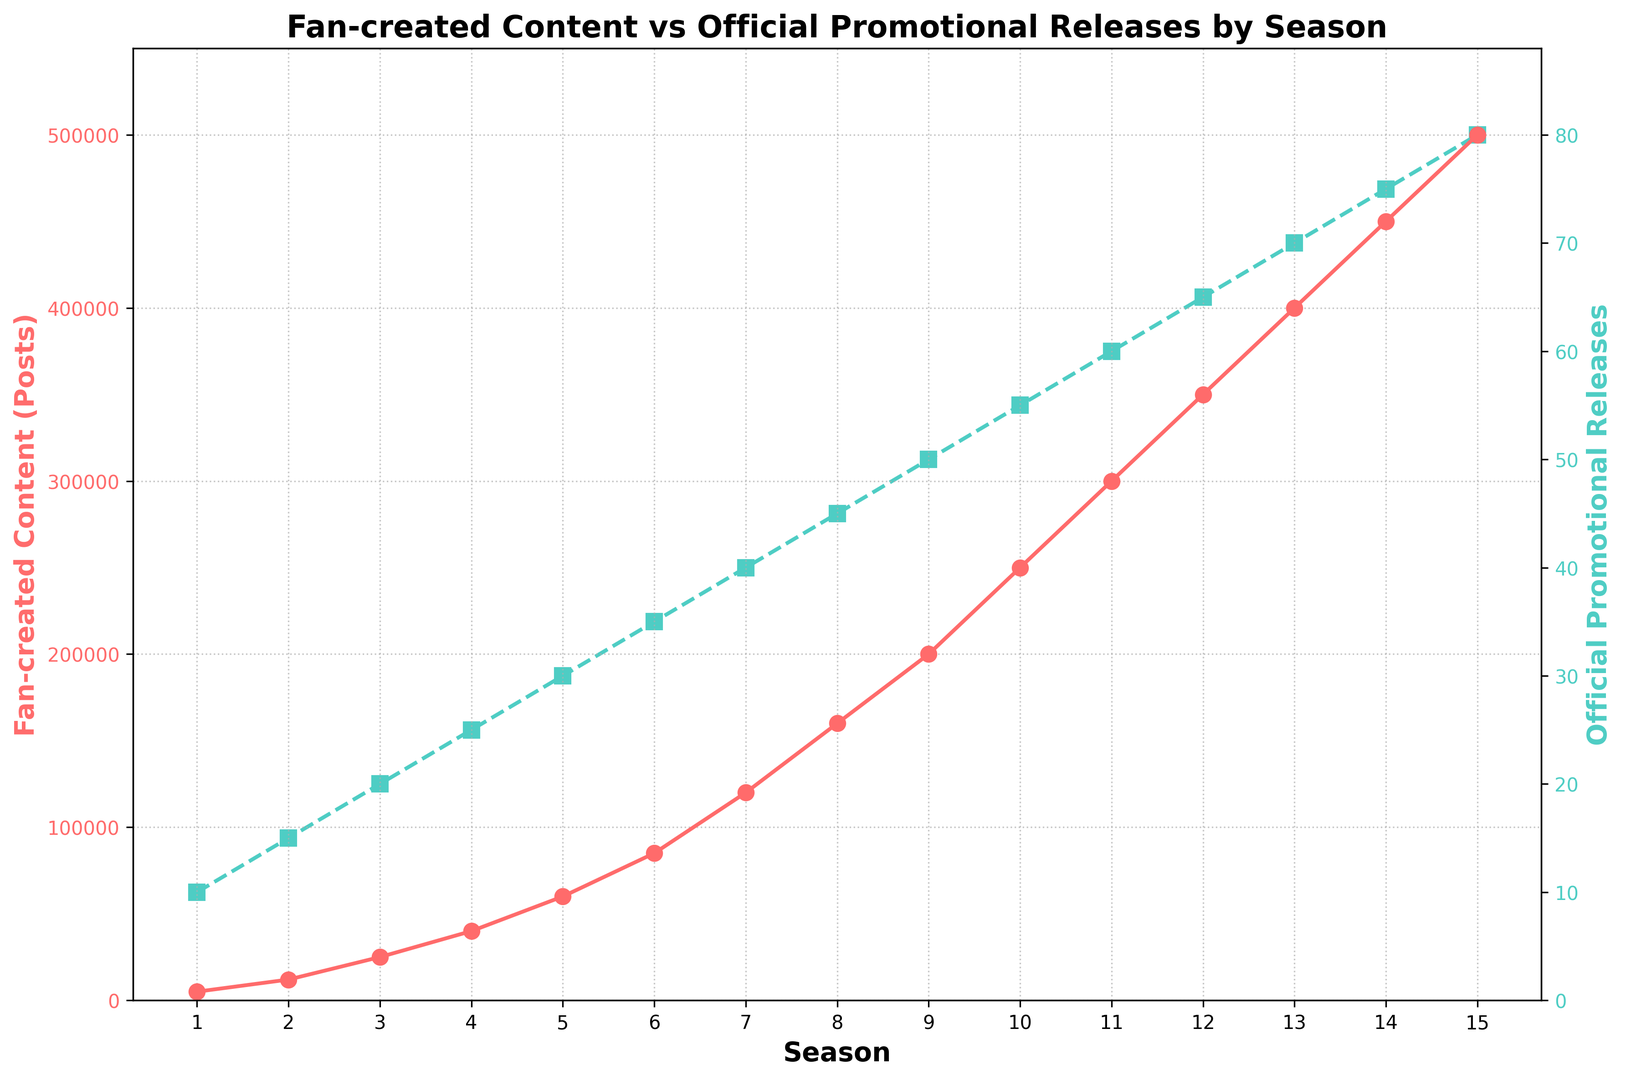How does the trend of Fan-created Content compare to Official Promotional Releases over the seasons? The Fan-created Content (Posts) consistently increases more steeply compared to Official Promotional Releases across all seasons as evidenced by the curve for Fan-created Content rising more sharply.
Answer: Fan-created Content increases more steeply In which season do Fan-created Content Posts and Official Promotional Releases show the maximum values? The maximum values for Fan-created Content Posts and Official Promotional Releases are in Season 15, where Fan-created Content posts reach 500,000, and Official Promotional Releases reach 80.
Answer: Season 15 What is the approximate ratio of Fan-created Content Posts to Official Promotional Releases in Season 10? The ratio of Fan-created Content Posts (250,000) to Official Promotional Releases (55) in Season 10 is approximately 250,000 / 55 ≈ 4545.
Answer: 4545 Between which consecutive seasons is there the largest increase in Fan-created Content Posts? The largest increase in Fan-created Content occurs between Season 8 (160,000 posts) and Season 9 (200,000 posts), which is an increase of 40,000 posts.
Answer: Between Season 8 and Season 9 Compare the rate of increase in Fan-created Content Posts with the rate of increase in Official Promotional Releases between Season 1 and Season 5. From Season 1 (5,000 posts) to Season 5 (60,000 posts), Fan-created Content Posts increase by 55,000. From Season 1 (10 releases) to Season 5 (30 releases), Official Promotional Releases increase by 20. The rate of increase for Fan-created Content is much higher.
Answer: Fan-created Content increases much more Which seasons show a similar rate of increase in both Fan-created Content Posts and Official Promotional Releases? Between Season 6 (85,000 posts, 35 releases) and Season 7 (120,000 posts, 40 releases), the increase is 35,000 posts and 5 releases respectively. This shows a similar incremental growth rate for both.
Answer: Between Season 6 and Season 7 Calculate the average number of Fan-created Content Posts over all seasons. Sum all the Fan-created Content Posts (5000 + 12000 + 25000 + 40000 + 60000 + 85000 + 120000 + 160000 + 200000 + 250000 + 300000 + 350000 + 400000 + 450000 + 500000) and divide by the number of seasons (15). The sum is 3,015,000, so the average is 3,015,000 / 15 = 201,000 posts per season.
Answer: 201,000 posts per season By what percentage does the Official Promotional Release increase from Season 1 to Season 15? Initial value is 10 releases (Season 1) and final value is 80 releases (Season 15). The percentage increase is calculated as ((80 - 10) / 10) * 100 = 700%.
Answer: 700% What visual indicators help differentiate between the data for Fan-created Content Posts and Official Promotional Releases? The Fan-created Content Posts are depicted with a red line and circle markers, while the Official Promotional Releases are represented with a green dashed line and square markers.
Answer: Red line with circles and green dashed line with squares Calculate the difference in the number of Fan-created Content Posts between Season 5 and Season 15. Subtract the number of Fan-created Content Posts in Season 5 (60,000) from that in Season 15 (500,000) to find the difference: 500,000 - 60,000 = 440,000.
Answer: 440,000 